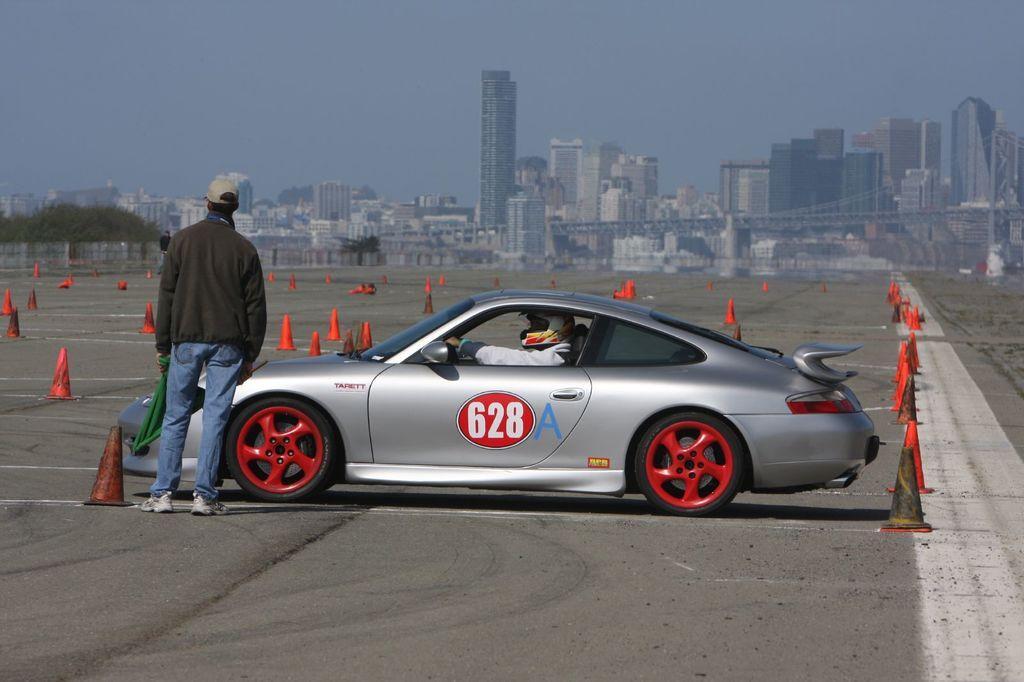In one or two sentences, can you explain what this image depicts? In this image I can see a car in the middle , in the car I can see a person in front of the car at the top I can see the building and the sky. 